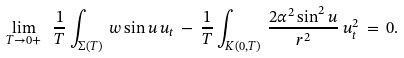Convert formula to latex. <formula><loc_0><loc_0><loc_500><loc_500>\lim _ { T \to 0 + } \ \frac { 1 } { T } \int _ { \Sigma ( T ) } \, w \sin u \, u _ { t } \, - \, \frac { 1 } { T } \int _ { K ( 0 , T ) } \, \frac { 2 \alpha ^ { 2 } \sin ^ { 2 } u } { r ^ { 2 } } \, u _ { t } ^ { 2 } \, = \, 0 .</formula> 